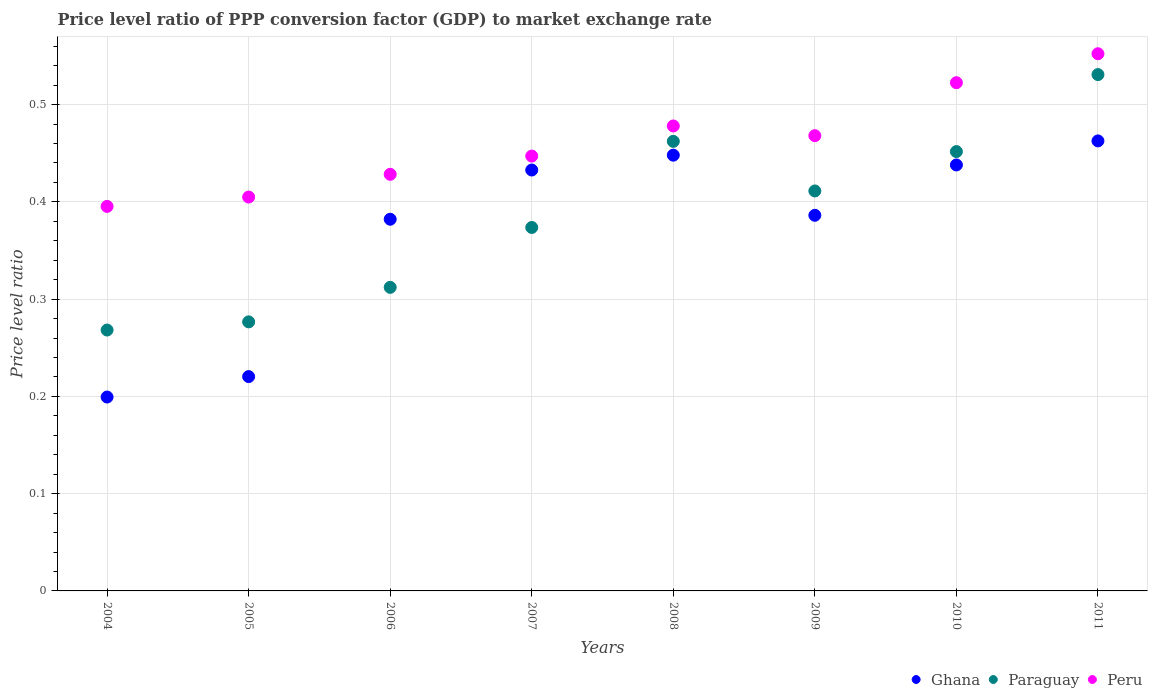How many different coloured dotlines are there?
Provide a short and direct response. 3. Is the number of dotlines equal to the number of legend labels?
Offer a very short reply. Yes. What is the price level ratio in Peru in 2009?
Offer a very short reply. 0.47. Across all years, what is the maximum price level ratio in Paraguay?
Make the answer very short. 0.53. Across all years, what is the minimum price level ratio in Peru?
Your answer should be compact. 0.4. In which year was the price level ratio in Peru minimum?
Offer a terse response. 2004. What is the total price level ratio in Paraguay in the graph?
Offer a very short reply. 3.09. What is the difference between the price level ratio in Ghana in 2009 and that in 2011?
Offer a very short reply. -0.08. What is the difference between the price level ratio in Peru in 2011 and the price level ratio in Ghana in 2008?
Your answer should be very brief. 0.1. What is the average price level ratio in Peru per year?
Offer a very short reply. 0.46. In the year 2011, what is the difference between the price level ratio in Ghana and price level ratio in Peru?
Make the answer very short. -0.09. What is the ratio of the price level ratio in Peru in 2006 to that in 2009?
Give a very brief answer. 0.92. Is the price level ratio in Ghana in 2008 less than that in 2009?
Make the answer very short. No. What is the difference between the highest and the second highest price level ratio in Peru?
Your answer should be very brief. 0.03. What is the difference between the highest and the lowest price level ratio in Paraguay?
Keep it short and to the point. 0.26. In how many years, is the price level ratio in Peru greater than the average price level ratio in Peru taken over all years?
Your answer should be compact. 4. Is it the case that in every year, the sum of the price level ratio in Ghana and price level ratio in Peru  is greater than the price level ratio in Paraguay?
Your answer should be compact. Yes. Is the price level ratio in Ghana strictly less than the price level ratio in Peru over the years?
Keep it short and to the point. Yes. How many years are there in the graph?
Your answer should be compact. 8. What is the difference between two consecutive major ticks on the Y-axis?
Make the answer very short. 0.1. How many legend labels are there?
Make the answer very short. 3. How are the legend labels stacked?
Keep it short and to the point. Horizontal. What is the title of the graph?
Offer a terse response. Price level ratio of PPP conversion factor (GDP) to market exchange rate. What is the label or title of the Y-axis?
Make the answer very short. Price level ratio. What is the Price level ratio of Ghana in 2004?
Provide a short and direct response. 0.2. What is the Price level ratio of Paraguay in 2004?
Your response must be concise. 0.27. What is the Price level ratio in Peru in 2004?
Give a very brief answer. 0.4. What is the Price level ratio in Ghana in 2005?
Your answer should be very brief. 0.22. What is the Price level ratio of Paraguay in 2005?
Make the answer very short. 0.28. What is the Price level ratio of Peru in 2005?
Keep it short and to the point. 0.4. What is the Price level ratio in Ghana in 2006?
Your answer should be compact. 0.38. What is the Price level ratio in Paraguay in 2006?
Make the answer very short. 0.31. What is the Price level ratio in Peru in 2006?
Your answer should be very brief. 0.43. What is the Price level ratio in Ghana in 2007?
Keep it short and to the point. 0.43. What is the Price level ratio of Paraguay in 2007?
Your answer should be very brief. 0.37. What is the Price level ratio in Peru in 2007?
Offer a terse response. 0.45. What is the Price level ratio in Ghana in 2008?
Offer a terse response. 0.45. What is the Price level ratio in Paraguay in 2008?
Keep it short and to the point. 0.46. What is the Price level ratio in Peru in 2008?
Your answer should be very brief. 0.48. What is the Price level ratio in Ghana in 2009?
Your response must be concise. 0.39. What is the Price level ratio of Paraguay in 2009?
Provide a short and direct response. 0.41. What is the Price level ratio of Peru in 2009?
Offer a terse response. 0.47. What is the Price level ratio of Ghana in 2010?
Provide a short and direct response. 0.44. What is the Price level ratio in Paraguay in 2010?
Your response must be concise. 0.45. What is the Price level ratio of Peru in 2010?
Provide a short and direct response. 0.52. What is the Price level ratio of Ghana in 2011?
Provide a succinct answer. 0.46. What is the Price level ratio of Paraguay in 2011?
Offer a terse response. 0.53. What is the Price level ratio in Peru in 2011?
Offer a terse response. 0.55. Across all years, what is the maximum Price level ratio in Ghana?
Give a very brief answer. 0.46. Across all years, what is the maximum Price level ratio of Paraguay?
Ensure brevity in your answer.  0.53. Across all years, what is the maximum Price level ratio in Peru?
Keep it short and to the point. 0.55. Across all years, what is the minimum Price level ratio in Ghana?
Provide a succinct answer. 0.2. Across all years, what is the minimum Price level ratio in Paraguay?
Your answer should be compact. 0.27. Across all years, what is the minimum Price level ratio in Peru?
Ensure brevity in your answer.  0.4. What is the total Price level ratio of Ghana in the graph?
Your response must be concise. 2.97. What is the total Price level ratio of Paraguay in the graph?
Make the answer very short. 3.09. What is the total Price level ratio in Peru in the graph?
Provide a short and direct response. 3.7. What is the difference between the Price level ratio in Ghana in 2004 and that in 2005?
Offer a very short reply. -0.02. What is the difference between the Price level ratio in Paraguay in 2004 and that in 2005?
Ensure brevity in your answer.  -0.01. What is the difference between the Price level ratio of Peru in 2004 and that in 2005?
Offer a very short reply. -0.01. What is the difference between the Price level ratio in Ghana in 2004 and that in 2006?
Give a very brief answer. -0.18. What is the difference between the Price level ratio in Paraguay in 2004 and that in 2006?
Give a very brief answer. -0.04. What is the difference between the Price level ratio of Peru in 2004 and that in 2006?
Make the answer very short. -0.03. What is the difference between the Price level ratio in Ghana in 2004 and that in 2007?
Give a very brief answer. -0.23. What is the difference between the Price level ratio of Paraguay in 2004 and that in 2007?
Keep it short and to the point. -0.11. What is the difference between the Price level ratio of Peru in 2004 and that in 2007?
Give a very brief answer. -0.05. What is the difference between the Price level ratio in Ghana in 2004 and that in 2008?
Provide a short and direct response. -0.25. What is the difference between the Price level ratio of Paraguay in 2004 and that in 2008?
Your answer should be compact. -0.19. What is the difference between the Price level ratio of Peru in 2004 and that in 2008?
Your answer should be very brief. -0.08. What is the difference between the Price level ratio in Ghana in 2004 and that in 2009?
Ensure brevity in your answer.  -0.19. What is the difference between the Price level ratio in Paraguay in 2004 and that in 2009?
Provide a short and direct response. -0.14. What is the difference between the Price level ratio in Peru in 2004 and that in 2009?
Make the answer very short. -0.07. What is the difference between the Price level ratio in Ghana in 2004 and that in 2010?
Offer a terse response. -0.24. What is the difference between the Price level ratio in Paraguay in 2004 and that in 2010?
Your answer should be very brief. -0.18. What is the difference between the Price level ratio of Peru in 2004 and that in 2010?
Provide a short and direct response. -0.13. What is the difference between the Price level ratio in Ghana in 2004 and that in 2011?
Your answer should be compact. -0.26. What is the difference between the Price level ratio of Paraguay in 2004 and that in 2011?
Ensure brevity in your answer.  -0.26. What is the difference between the Price level ratio in Peru in 2004 and that in 2011?
Offer a very short reply. -0.16. What is the difference between the Price level ratio in Ghana in 2005 and that in 2006?
Provide a succinct answer. -0.16. What is the difference between the Price level ratio in Paraguay in 2005 and that in 2006?
Offer a terse response. -0.04. What is the difference between the Price level ratio in Peru in 2005 and that in 2006?
Provide a succinct answer. -0.02. What is the difference between the Price level ratio of Ghana in 2005 and that in 2007?
Give a very brief answer. -0.21. What is the difference between the Price level ratio of Paraguay in 2005 and that in 2007?
Offer a very short reply. -0.1. What is the difference between the Price level ratio in Peru in 2005 and that in 2007?
Your answer should be compact. -0.04. What is the difference between the Price level ratio in Ghana in 2005 and that in 2008?
Make the answer very short. -0.23. What is the difference between the Price level ratio in Paraguay in 2005 and that in 2008?
Provide a short and direct response. -0.19. What is the difference between the Price level ratio in Peru in 2005 and that in 2008?
Provide a short and direct response. -0.07. What is the difference between the Price level ratio in Ghana in 2005 and that in 2009?
Offer a terse response. -0.17. What is the difference between the Price level ratio of Paraguay in 2005 and that in 2009?
Offer a terse response. -0.13. What is the difference between the Price level ratio of Peru in 2005 and that in 2009?
Offer a very short reply. -0.06. What is the difference between the Price level ratio in Ghana in 2005 and that in 2010?
Give a very brief answer. -0.22. What is the difference between the Price level ratio of Paraguay in 2005 and that in 2010?
Ensure brevity in your answer.  -0.17. What is the difference between the Price level ratio of Peru in 2005 and that in 2010?
Provide a short and direct response. -0.12. What is the difference between the Price level ratio of Ghana in 2005 and that in 2011?
Ensure brevity in your answer.  -0.24. What is the difference between the Price level ratio of Paraguay in 2005 and that in 2011?
Offer a terse response. -0.25. What is the difference between the Price level ratio in Peru in 2005 and that in 2011?
Provide a succinct answer. -0.15. What is the difference between the Price level ratio in Ghana in 2006 and that in 2007?
Ensure brevity in your answer.  -0.05. What is the difference between the Price level ratio in Paraguay in 2006 and that in 2007?
Offer a terse response. -0.06. What is the difference between the Price level ratio in Peru in 2006 and that in 2007?
Keep it short and to the point. -0.02. What is the difference between the Price level ratio of Ghana in 2006 and that in 2008?
Your answer should be very brief. -0.07. What is the difference between the Price level ratio of Paraguay in 2006 and that in 2008?
Your response must be concise. -0.15. What is the difference between the Price level ratio in Peru in 2006 and that in 2008?
Provide a short and direct response. -0.05. What is the difference between the Price level ratio of Ghana in 2006 and that in 2009?
Offer a very short reply. -0. What is the difference between the Price level ratio in Paraguay in 2006 and that in 2009?
Your answer should be compact. -0.1. What is the difference between the Price level ratio of Peru in 2006 and that in 2009?
Ensure brevity in your answer.  -0.04. What is the difference between the Price level ratio of Ghana in 2006 and that in 2010?
Your answer should be compact. -0.06. What is the difference between the Price level ratio in Paraguay in 2006 and that in 2010?
Offer a terse response. -0.14. What is the difference between the Price level ratio in Peru in 2006 and that in 2010?
Provide a short and direct response. -0.09. What is the difference between the Price level ratio of Ghana in 2006 and that in 2011?
Offer a very short reply. -0.08. What is the difference between the Price level ratio in Paraguay in 2006 and that in 2011?
Offer a very short reply. -0.22. What is the difference between the Price level ratio of Peru in 2006 and that in 2011?
Offer a very short reply. -0.12. What is the difference between the Price level ratio of Ghana in 2007 and that in 2008?
Provide a succinct answer. -0.02. What is the difference between the Price level ratio in Paraguay in 2007 and that in 2008?
Ensure brevity in your answer.  -0.09. What is the difference between the Price level ratio of Peru in 2007 and that in 2008?
Your answer should be very brief. -0.03. What is the difference between the Price level ratio in Ghana in 2007 and that in 2009?
Provide a short and direct response. 0.05. What is the difference between the Price level ratio in Paraguay in 2007 and that in 2009?
Provide a succinct answer. -0.04. What is the difference between the Price level ratio in Peru in 2007 and that in 2009?
Your response must be concise. -0.02. What is the difference between the Price level ratio in Ghana in 2007 and that in 2010?
Make the answer very short. -0.01. What is the difference between the Price level ratio of Paraguay in 2007 and that in 2010?
Provide a short and direct response. -0.08. What is the difference between the Price level ratio in Peru in 2007 and that in 2010?
Your response must be concise. -0.08. What is the difference between the Price level ratio in Ghana in 2007 and that in 2011?
Your answer should be compact. -0.03. What is the difference between the Price level ratio in Paraguay in 2007 and that in 2011?
Offer a very short reply. -0.16. What is the difference between the Price level ratio of Peru in 2007 and that in 2011?
Keep it short and to the point. -0.11. What is the difference between the Price level ratio in Ghana in 2008 and that in 2009?
Provide a short and direct response. 0.06. What is the difference between the Price level ratio in Paraguay in 2008 and that in 2009?
Make the answer very short. 0.05. What is the difference between the Price level ratio of Peru in 2008 and that in 2009?
Provide a short and direct response. 0.01. What is the difference between the Price level ratio of Ghana in 2008 and that in 2010?
Your answer should be compact. 0.01. What is the difference between the Price level ratio in Paraguay in 2008 and that in 2010?
Your response must be concise. 0.01. What is the difference between the Price level ratio of Peru in 2008 and that in 2010?
Provide a succinct answer. -0.04. What is the difference between the Price level ratio of Ghana in 2008 and that in 2011?
Provide a short and direct response. -0.01. What is the difference between the Price level ratio in Paraguay in 2008 and that in 2011?
Offer a very short reply. -0.07. What is the difference between the Price level ratio in Peru in 2008 and that in 2011?
Give a very brief answer. -0.07. What is the difference between the Price level ratio in Ghana in 2009 and that in 2010?
Provide a short and direct response. -0.05. What is the difference between the Price level ratio in Paraguay in 2009 and that in 2010?
Your answer should be compact. -0.04. What is the difference between the Price level ratio in Peru in 2009 and that in 2010?
Offer a very short reply. -0.05. What is the difference between the Price level ratio of Ghana in 2009 and that in 2011?
Your answer should be compact. -0.08. What is the difference between the Price level ratio in Paraguay in 2009 and that in 2011?
Offer a terse response. -0.12. What is the difference between the Price level ratio in Peru in 2009 and that in 2011?
Make the answer very short. -0.08. What is the difference between the Price level ratio in Ghana in 2010 and that in 2011?
Ensure brevity in your answer.  -0.02. What is the difference between the Price level ratio of Paraguay in 2010 and that in 2011?
Your answer should be very brief. -0.08. What is the difference between the Price level ratio of Peru in 2010 and that in 2011?
Make the answer very short. -0.03. What is the difference between the Price level ratio of Ghana in 2004 and the Price level ratio of Paraguay in 2005?
Your response must be concise. -0.08. What is the difference between the Price level ratio of Ghana in 2004 and the Price level ratio of Peru in 2005?
Ensure brevity in your answer.  -0.21. What is the difference between the Price level ratio of Paraguay in 2004 and the Price level ratio of Peru in 2005?
Give a very brief answer. -0.14. What is the difference between the Price level ratio in Ghana in 2004 and the Price level ratio in Paraguay in 2006?
Your response must be concise. -0.11. What is the difference between the Price level ratio of Ghana in 2004 and the Price level ratio of Peru in 2006?
Keep it short and to the point. -0.23. What is the difference between the Price level ratio of Paraguay in 2004 and the Price level ratio of Peru in 2006?
Offer a very short reply. -0.16. What is the difference between the Price level ratio of Ghana in 2004 and the Price level ratio of Paraguay in 2007?
Your answer should be very brief. -0.17. What is the difference between the Price level ratio of Ghana in 2004 and the Price level ratio of Peru in 2007?
Your answer should be compact. -0.25. What is the difference between the Price level ratio in Paraguay in 2004 and the Price level ratio in Peru in 2007?
Make the answer very short. -0.18. What is the difference between the Price level ratio of Ghana in 2004 and the Price level ratio of Paraguay in 2008?
Offer a terse response. -0.26. What is the difference between the Price level ratio in Ghana in 2004 and the Price level ratio in Peru in 2008?
Your answer should be very brief. -0.28. What is the difference between the Price level ratio in Paraguay in 2004 and the Price level ratio in Peru in 2008?
Your response must be concise. -0.21. What is the difference between the Price level ratio in Ghana in 2004 and the Price level ratio in Paraguay in 2009?
Provide a succinct answer. -0.21. What is the difference between the Price level ratio of Ghana in 2004 and the Price level ratio of Peru in 2009?
Your answer should be compact. -0.27. What is the difference between the Price level ratio of Paraguay in 2004 and the Price level ratio of Peru in 2009?
Your answer should be very brief. -0.2. What is the difference between the Price level ratio in Ghana in 2004 and the Price level ratio in Paraguay in 2010?
Your response must be concise. -0.25. What is the difference between the Price level ratio of Ghana in 2004 and the Price level ratio of Peru in 2010?
Give a very brief answer. -0.32. What is the difference between the Price level ratio in Paraguay in 2004 and the Price level ratio in Peru in 2010?
Ensure brevity in your answer.  -0.25. What is the difference between the Price level ratio of Ghana in 2004 and the Price level ratio of Paraguay in 2011?
Offer a very short reply. -0.33. What is the difference between the Price level ratio of Ghana in 2004 and the Price level ratio of Peru in 2011?
Provide a short and direct response. -0.35. What is the difference between the Price level ratio of Paraguay in 2004 and the Price level ratio of Peru in 2011?
Ensure brevity in your answer.  -0.28. What is the difference between the Price level ratio of Ghana in 2005 and the Price level ratio of Paraguay in 2006?
Your answer should be very brief. -0.09. What is the difference between the Price level ratio of Ghana in 2005 and the Price level ratio of Peru in 2006?
Ensure brevity in your answer.  -0.21. What is the difference between the Price level ratio in Paraguay in 2005 and the Price level ratio in Peru in 2006?
Your answer should be very brief. -0.15. What is the difference between the Price level ratio in Ghana in 2005 and the Price level ratio in Paraguay in 2007?
Keep it short and to the point. -0.15. What is the difference between the Price level ratio in Ghana in 2005 and the Price level ratio in Peru in 2007?
Ensure brevity in your answer.  -0.23. What is the difference between the Price level ratio of Paraguay in 2005 and the Price level ratio of Peru in 2007?
Make the answer very short. -0.17. What is the difference between the Price level ratio in Ghana in 2005 and the Price level ratio in Paraguay in 2008?
Provide a succinct answer. -0.24. What is the difference between the Price level ratio of Ghana in 2005 and the Price level ratio of Peru in 2008?
Your response must be concise. -0.26. What is the difference between the Price level ratio in Paraguay in 2005 and the Price level ratio in Peru in 2008?
Offer a very short reply. -0.2. What is the difference between the Price level ratio of Ghana in 2005 and the Price level ratio of Paraguay in 2009?
Make the answer very short. -0.19. What is the difference between the Price level ratio of Ghana in 2005 and the Price level ratio of Peru in 2009?
Provide a succinct answer. -0.25. What is the difference between the Price level ratio of Paraguay in 2005 and the Price level ratio of Peru in 2009?
Ensure brevity in your answer.  -0.19. What is the difference between the Price level ratio in Ghana in 2005 and the Price level ratio in Paraguay in 2010?
Offer a very short reply. -0.23. What is the difference between the Price level ratio of Ghana in 2005 and the Price level ratio of Peru in 2010?
Your answer should be compact. -0.3. What is the difference between the Price level ratio of Paraguay in 2005 and the Price level ratio of Peru in 2010?
Provide a succinct answer. -0.25. What is the difference between the Price level ratio in Ghana in 2005 and the Price level ratio in Paraguay in 2011?
Provide a succinct answer. -0.31. What is the difference between the Price level ratio in Ghana in 2005 and the Price level ratio in Peru in 2011?
Provide a succinct answer. -0.33. What is the difference between the Price level ratio in Paraguay in 2005 and the Price level ratio in Peru in 2011?
Your answer should be compact. -0.28. What is the difference between the Price level ratio in Ghana in 2006 and the Price level ratio in Paraguay in 2007?
Provide a succinct answer. 0.01. What is the difference between the Price level ratio of Ghana in 2006 and the Price level ratio of Peru in 2007?
Give a very brief answer. -0.07. What is the difference between the Price level ratio of Paraguay in 2006 and the Price level ratio of Peru in 2007?
Your answer should be very brief. -0.14. What is the difference between the Price level ratio in Ghana in 2006 and the Price level ratio in Paraguay in 2008?
Offer a very short reply. -0.08. What is the difference between the Price level ratio in Ghana in 2006 and the Price level ratio in Peru in 2008?
Offer a very short reply. -0.1. What is the difference between the Price level ratio in Paraguay in 2006 and the Price level ratio in Peru in 2008?
Your answer should be compact. -0.17. What is the difference between the Price level ratio in Ghana in 2006 and the Price level ratio in Paraguay in 2009?
Give a very brief answer. -0.03. What is the difference between the Price level ratio of Ghana in 2006 and the Price level ratio of Peru in 2009?
Your answer should be very brief. -0.09. What is the difference between the Price level ratio of Paraguay in 2006 and the Price level ratio of Peru in 2009?
Your answer should be very brief. -0.16. What is the difference between the Price level ratio in Ghana in 2006 and the Price level ratio in Paraguay in 2010?
Ensure brevity in your answer.  -0.07. What is the difference between the Price level ratio of Ghana in 2006 and the Price level ratio of Peru in 2010?
Give a very brief answer. -0.14. What is the difference between the Price level ratio in Paraguay in 2006 and the Price level ratio in Peru in 2010?
Provide a short and direct response. -0.21. What is the difference between the Price level ratio of Ghana in 2006 and the Price level ratio of Paraguay in 2011?
Ensure brevity in your answer.  -0.15. What is the difference between the Price level ratio in Ghana in 2006 and the Price level ratio in Peru in 2011?
Your answer should be compact. -0.17. What is the difference between the Price level ratio in Paraguay in 2006 and the Price level ratio in Peru in 2011?
Offer a very short reply. -0.24. What is the difference between the Price level ratio of Ghana in 2007 and the Price level ratio of Paraguay in 2008?
Provide a short and direct response. -0.03. What is the difference between the Price level ratio in Ghana in 2007 and the Price level ratio in Peru in 2008?
Provide a short and direct response. -0.05. What is the difference between the Price level ratio of Paraguay in 2007 and the Price level ratio of Peru in 2008?
Your answer should be very brief. -0.1. What is the difference between the Price level ratio of Ghana in 2007 and the Price level ratio of Paraguay in 2009?
Provide a succinct answer. 0.02. What is the difference between the Price level ratio in Ghana in 2007 and the Price level ratio in Peru in 2009?
Your answer should be compact. -0.04. What is the difference between the Price level ratio in Paraguay in 2007 and the Price level ratio in Peru in 2009?
Your response must be concise. -0.09. What is the difference between the Price level ratio of Ghana in 2007 and the Price level ratio of Paraguay in 2010?
Give a very brief answer. -0.02. What is the difference between the Price level ratio of Ghana in 2007 and the Price level ratio of Peru in 2010?
Ensure brevity in your answer.  -0.09. What is the difference between the Price level ratio in Paraguay in 2007 and the Price level ratio in Peru in 2010?
Provide a short and direct response. -0.15. What is the difference between the Price level ratio in Ghana in 2007 and the Price level ratio in Paraguay in 2011?
Offer a terse response. -0.1. What is the difference between the Price level ratio in Ghana in 2007 and the Price level ratio in Peru in 2011?
Provide a succinct answer. -0.12. What is the difference between the Price level ratio in Paraguay in 2007 and the Price level ratio in Peru in 2011?
Give a very brief answer. -0.18. What is the difference between the Price level ratio of Ghana in 2008 and the Price level ratio of Paraguay in 2009?
Your response must be concise. 0.04. What is the difference between the Price level ratio of Ghana in 2008 and the Price level ratio of Peru in 2009?
Your answer should be compact. -0.02. What is the difference between the Price level ratio of Paraguay in 2008 and the Price level ratio of Peru in 2009?
Offer a terse response. -0.01. What is the difference between the Price level ratio in Ghana in 2008 and the Price level ratio in Paraguay in 2010?
Offer a very short reply. -0. What is the difference between the Price level ratio in Ghana in 2008 and the Price level ratio in Peru in 2010?
Give a very brief answer. -0.07. What is the difference between the Price level ratio in Paraguay in 2008 and the Price level ratio in Peru in 2010?
Make the answer very short. -0.06. What is the difference between the Price level ratio in Ghana in 2008 and the Price level ratio in Paraguay in 2011?
Make the answer very short. -0.08. What is the difference between the Price level ratio of Ghana in 2008 and the Price level ratio of Peru in 2011?
Offer a very short reply. -0.1. What is the difference between the Price level ratio in Paraguay in 2008 and the Price level ratio in Peru in 2011?
Offer a terse response. -0.09. What is the difference between the Price level ratio in Ghana in 2009 and the Price level ratio in Paraguay in 2010?
Ensure brevity in your answer.  -0.07. What is the difference between the Price level ratio in Ghana in 2009 and the Price level ratio in Peru in 2010?
Your answer should be very brief. -0.14. What is the difference between the Price level ratio in Paraguay in 2009 and the Price level ratio in Peru in 2010?
Ensure brevity in your answer.  -0.11. What is the difference between the Price level ratio of Ghana in 2009 and the Price level ratio of Paraguay in 2011?
Offer a very short reply. -0.14. What is the difference between the Price level ratio of Ghana in 2009 and the Price level ratio of Peru in 2011?
Provide a short and direct response. -0.17. What is the difference between the Price level ratio in Paraguay in 2009 and the Price level ratio in Peru in 2011?
Make the answer very short. -0.14. What is the difference between the Price level ratio in Ghana in 2010 and the Price level ratio in Paraguay in 2011?
Give a very brief answer. -0.09. What is the difference between the Price level ratio in Ghana in 2010 and the Price level ratio in Peru in 2011?
Provide a succinct answer. -0.11. What is the difference between the Price level ratio in Paraguay in 2010 and the Price level ratio in Peru in 2011?
Keep it short and to the point. -0.1. What is the average Price level ratio in Ghana per year?
Provide a succinct answer. 0.37. What is the average Price level ratio of Paraguay per year?
Ensure brevity in your answer.  0.39. What is the average Price level ratio in Peru per year?
Your response must be concise. 0.46. In the year 2004, what is the difference between the Price level ratio of Ghana and Price level ratio of Paraguay?
Make the answer very short. -0.07. In the year 2004, what is the difference between the Price level ratio in Ghana and Price level ratio in Peru?
Your response must be concise. -0.2. In the year 2004, what is the difference between the Price level ratio in Paraguay and Price level ratio in Peru?
Your answer should be very brief. -0.13. In the year 2005, what is the difference between the Price level ratio in Ghana and Price level ratio in Paraguay?
Your response must be concise. -0.06. In the year 2005, what is the difference between the Price level ratio of Ghana and Price level ratio of Peru?
Ensure brevity in your answer.  -0.18. In the year 2005, what is the difference between the Price level ratio in Paraguay and Price level ratio in Peru?
Your answer should be very brief. -0.13. In the year 2006, what is the difference between the Price level ratio of Ghana and Price level ratio of Paraguay?
Your response must be concise. 0.07. In the year 2006, what is the difference between the Price level ratio in Ghana and Price level ratio in Peru?
Offer a very short reply. -0.05. In the year 2006, what is the difference between the Price level ratio of Paraguay and Price level ratio of Peru?
Keep it short and to the point. -0.12. In the year 2007, what is the difference between the Price level ratio of Ghana and Price level ratio of Paraguay?
Offer a terse response. 0.06. In the year 2007, what is the difference between the Price level ratio of Ghana and Price level ratio of Peru?
Your answer should be compact. -0.01. In the year 2007, what is the difference between the Price level ratio of Paraguay and Price level ratio of Peru?
Make the answer very short. -0.07. In the year 2008, what is the difference between the Price level ratio of Ghana and Price level ratio of Paraguay?
Ensure brevity in your answer.  -0.01. In the year 2008, what is the difference between the Price level ratio of Ghana and Price level ratio of Peru?
Provide a short and direct response. -0.03. In the year 2008, what is the difference between the Price level ratio in Paraguay and Price level ratio in Peru?
Provide a succinct answer. -0.02. In the year 2009, what is the difference between the Price level ratio in Ghana and Price level ratio in Paraguay?
Ensure brevity in your answer.  -0.03. In the year 2009, what is the difference between the Price level ratio of Ghana and Price level ratio of Peru?
Offer a very short reply. -0.08. In the year 2009, what is the difference between the Price level ratio of Paraguay and Price level ratio of Peru?
Provide a succinct answer. -0.06. In the year 2010, what is the difference between the Price level ratio of Ghana and Price level ratio of Paraguay?
Your answer should be compact. -0.01. In the year 2010, what is the difference between the Price level ratio in Ghana and Price level ratio in Peru?
Ensure brevity in your answer.  -0.08. In the year 2010, what is the difference between the Price level ratio of Paraguay and Price level ratio of Peru?
Offer a very short reply. -0.07. In the year 2011, what is the difference between the Price level ratio of Ghana and Price level ratio of Paraguay?
Offer a terse response. -0.07. In the year 2011, what is the difference between the Price level ratio in Ghana and Price level ratio in Peru?
Provide a short and direct response. -0.09. In the year 2011, what is the difference between the Price level ratio in Paraguay and Price level ratio in Peru?
Keep it short and to the point. -0.02. What is the ratio of the Price level ratio of Ghana in 2004 to that in 2005?
Offer a terse response. 0.9. What is the ratio of the Price level ratio in Paraguay in 2004 to that in 2005?
Make the answer very short. 0.97. What is the ratio of the Price level ratio in Peru in 2004 to that in 2005?
Keep it short and to the point. 0.98. What is the ratio of the Price level ratio of Ghana in 2004 to that in 2006?
Ensure brevity in your answer.  0.52. What is the ratio of the Price level ratio of Paraguay in 2004 to that in 2006?
Ensure brevity in your answer.  0.86. What is the ratio of the Price level ratio of Peru in 2004 to that in 2006?
Offer a very short reply. 0.92. What is the ratio of the Price level ratio in Ghana in 2004 to that in 2007?
Provide a succinct answer. 0.46. What is the ratio of the Price level ratio in Paraguay in 2004 to that in 2007?
Keep it short and to the point. 0.72. What is the ratio of the Price level ratio of Peru in 2004 to that in 2007?
Your answer should be very brief. 0.88. What is the ratio of the Price level ratio in Ghana in 2004 to that in 2008?
Your answer should be compact. 0.44. What is the ratio of the Price level ratio of Paraguay in 2004 to that in 2008?
Keep it short and to the point. 0.58. What is the ratio of the Price level ratio in Peru in 2004 to that in 2008?
Offer a terse response. 0.83. What is the ratio of the Price level ratio of Ghana in 2004 to that in 2009?
Keep it short and to the point. 0.52. What is the ratio of the Price level ratio in Paraguay in 2004 to that in 2009?
Your answer should be very brief. 0.65. What is the ratio of the Price level ratio of Peru in 2004 to that in 2009?
Your response must be concise. 0.84. What is the ratio of the Price level ratio in Ghana in 2004 to that in 2010?
Offer a terse response. 0.46. What is the ratio of the Price level ratio in Paraguay in 2004 to that in 2010?
Your answer should be very brief. 0.59. What is the ratio of the Price level ratio of Peru in 2004 to that in 2010?
Give a very brief answer. 0.76. What is the ratio of the Price level ratio of Ghana in 2004 to that in 2011?
Ensure brevity in your answer.  0.43. What is the ratio of the Price level ratio of Paraguay in 2004 to that in 2011?
Your answer should be compact. 0.51. What is the ratio of the Price level ratio in Peru in 2004 to that in 2011?
Keep it short and to the point. 0.72. What is the ratio of the Price level ratio of Ghana in 2005 to that in 2006?
Your answer should be very brief. 0.58. What is the ratio of the Price level ratio of Paraguay in 2005 to that in 2006?
Your response must be concise. 0.89. What is the ratio of the Price level ratio of Peru in 2005 to that in 2006?
Offer a very short reply. 0.95. What is the ratio of the Price level ratio in Ghana in 2005 to that in 2007?
Provide a short and direct response. 0.51. What is the ratio of the Price level ratio of Paraguay in 2005 to that in 2007?
Make the answer very short. 0.74. What is the ratio of the Price level ratio in Peru in 2005 to that in 2007?
Your response must be concise. 0.91. What is the ratio of the Price level ratio in Ghana in 2005 to that in 2008?
Provide a short and direct response. 0.49. What is the ratio of the Price level ratio in Paraguay in 2005 to that in 2008?
Provide a succinct answer. 0.6. What is the ratio of the Price level ratio in Peru in 2005 to that in 2008?
Give a very brief answer. 0.85. What is the ratio of the Price level ratio in Ghana in 2005 to that in 2009?
Offer a very short reply. 0.57. What is the ratio of the Price level ratio of Paraguay in 2005 to that in 2009?
Keep it short and to the point. 0.67. What is the ratio of the Price level ratio of Peru in 2005 to that in 2009?
Your response must be concise. 0.87. What is the ratio of the Price level ratio in Ghana in 2005 to that in 2010?
Offer a terse response. 0.5. What is the ratio of the Price level ratio of Paraguay in 2005 to that in 2010?
Keep it short and to the point. 0.61. What is the ratio of the Price level ratio in Peru in 2005 to that in 2010?
Keep it short and to the point. 0.78. What is the ratio of the Price level ratio in Ghana in 2005 to that in 2011?
Offer a very short reply. 0.48. What is the ratio of the Price level ratio in Paraguay in 2005 to that in 2011?
Offer a terse response. 0.52. What is the ratio of the Price level ratio in Peru in 2005 to that in 2011?
Ensure brevity in your answer.  0.73. What is the ratio of the Price level ratio of Ghana in 2006 to that in 2007?
Offer a very short reply. 0.88. What is the ratio of the Price level ratio in Paraguay in 2006 to that in 2007?
Make the answer very short. 0.84. What is the ratio of the Price level ratio in Peru in 2006 to that in 2007?
Offer a very short reply. 0.96. What is the ratio of the Price level ratio of Ghana in 2006 to that in 2008?
Ensure brevity in your answer.  0.85. What is the ratio of the Price level ratio in Paraguay in 2006 to that in 2008?
Ensure brevity in your answer.  0.68. What is the ratio of the Price level ratio in Peru in 2006 to that in 2008?
Offer a terse response. 0.9. What is the ratio of the Price level ratio in Ghana in 2006 to that in 2009?
Offer a very short reply. 0.99. What is the ratio of the Price level ratio in Paraguay in 2006 to that in 2009?
Offer a very short reply. 0.76. What is the ratio of the Price level ratio of Peru in 2006 to that in 2009?
Offer a very short reply. 0.92. What is the ratio of the Price level ratio of Ghana in 2006 to that in 2010?
Provide a short and direct response. 0.87. What is the ratio of the Price level ratio of Paraguay in 2006 to that in 2010?
Offer a terse response. 0.69. What is the ratio of the Price level ratio in Peru in 2006 to that in 2010?
Ensure brevity in your answer.  0.82. What is the ratio of the Price level ratio of Ghana in 2006 to that in 2011?
Provide a short and direct response. 0.83. What is the ratio of the Price level ratio of Paraguay in 2006 to that in 2011?
Give a very brief answer. 0.59. What is the ratio of the Price level ratio of Peru in 2006 to that in 2011?
Offer a terse response. 0.78. What is the ratio of the Price level ratio in Ghana in 2007 to that in 2008?
Your answer should be very brief. 0.97. What is the ratio of the Price level ratio of Paraguay in 2007 to that in 2008?
Your response must be concise. 0.81. What is the ratio of the Price level ratio of Peru in 2007 to that in 2008?
Ensure brevity in your answer.  0.94. What is the ratio of the Price level ratio in Ghana in 2007 to that in 2009?
Your response must be concise. 1.12. What is the ratio of the Price level ratio of Paraguay in 2007 to that in 2009?
Provide a short and direct response. 0.91. What is the ratio of the Price level ratio in Peru in 2007 to that in 2009?
Offer a very short reply. 0.96. What is the ratio of the Price level ratio in Paraguay in 2007 to that in 2010?
Offer a terse response. 0.83. What is the ratio of the Price level ratio in Peru in 2007 to that in 2010?
Your answer should be very brief. 0.86. What is the ratio of the Price level ratio in Ghana in 2007 to that in 2011?
Provide a short and direct response. 0.94. What is the ratio of the Price level ratio in Paraguay in 2007 to that in 2011?
Your response must be concise. 0.7. What is the ratio of the Price level ratio of Peru in 2007 to that in 2011?
Your response must be concise. 0.81. What is the ratio of the Price level ratio of Ghana in 2008 to that in 2009?
Give a very brief answer. 1.16. What is the ratio of the Price level ratio in Paraguay in 2008 to that in 2009?
Offer a terse response. 1.12. What is the ratio of the Price level ratio of Peru in 2008 to that in 2009?
Make the answer very short. 1.02. What is the ratio of the Price level ratio in Paraguay in 2008 to that in 2010?
Your answer should be very brief. 1.02. What is the ratio of the Price level ratio in Peru in 2008 to that in 2010?
Offer a very short reply. 0.91. What is the ratio of the Price level ratio of Ghana in 2008 to that in 2011?
Offer a very short reply. 0.97. What is the ratio of the Price level ratio in Paraguay in 2008 to that in 2011?
Make the answer very short. 0.87. What is the ratio of the Price level ratio in Peru in 2008 to that in 2011?
Your response must be concise. 0.87. What is the ratio of the Price level ratio in Ghana in 2009 to that in 2010?
Your response must be concise. 0.88. What is the ratio of the Price level ratio in Paraguay in 2009 to that in 2010?
Your answer should be very brief. 0.91. What is the ratio of the Price level ratio in Peru in 2009 to that in 2010?
Provide a short and direct response. 0.9. What is the ratio of the Price level ratio of Ghana in 2009 to that in 2011?
Offer a terse response. 0.83. What is the ratio of the Price level ratio in Paraguay in 2009 to that in 2011?
Ensure brevity in your answer.  0.77. What is the ratio of the Price level ratio of Peru in 2009 to that in 2011?
Provide a succinct answer. 0.85. What is the ratio of the Price level ratio of Ghana in 2010 to that in 2011?
Provide a short and direct response. 0.95. What is the ratio of the Price level ratio of Paraguay in 2010 to that in 2011?
Offer a very short reply. 0.85. What is the ratio of the Price level ratio in Peru in 2010 to that in 2011?
Your answer should be compact. 0.95. What is the difference between the highest and the second highest Price level ratio in Ghana?
Make the answer very short. 0.01. What is the difference between the highest and the second highest Price level ratio in Paraguay?
Your response must be concise. 0.07. What is the difference between the highest and the second highest Price level ratio of Peru?
Offer a terse response. 0.03. What is the difference between the highest and the lowest Price level ratio in Ghana?
Offer a terse response. 0.26. What is the difference between the highest and the lowest Price level ratio of Paraguay?
Offer a terse response. 0.26. What is the difference between the highest and the lowest Price level ratio of Peru?
Provide a short and direct response. 0.16. 